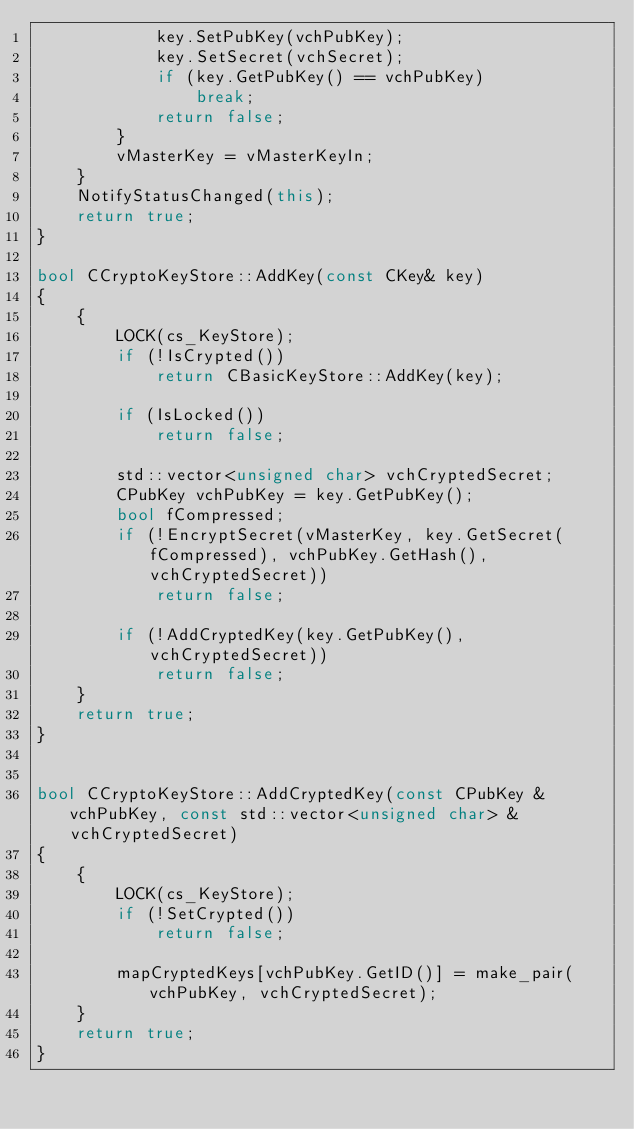<code> <loc_0><loc_0><loc_500><loc_500><_C++_>            key.SetPubKey(vchPubKey);
            key.SetSecret(vchSecret);
            if (key.GetPubKey() == vchPubKey)
                break;
            return false;
        }
        vMasterKey = vMasterKeyIn;
    }
    NotifyStatusChanged(this);
    return true;
}

bool CCryptoKeyStore::AddKey(const CKey& key)
{
    {
        LOCK(cs_KeyStore);
        if (!IsCrypted())
            return CBasicKeyStore::AddKey(key);

        if (IsLocked())
            return false;

        std::vector<unsigned char> vchCryptedSecret;
        CPubKey vchPubKey = key.GetPubKey();
        bool fCompressed;
        if (!EncryptSecret(vMasterKey, key.GetSecret(fCompressed), vchPubKey.GetHash(), vchCryptedSecret))
            return false;

        if (!AddCryptedKey(key.GetPubKey(), vchCryptedSecret))
            return false;
    }
    return true;
}


bool CCryptoKeyStore::AddCryptedKey(const CPubKey &vchPubKey, const std::vector<unsigned char> &vchCryptedSecret)
{
    {
        LOCK(cs_KeyStore);
        if (!SetCrypted())
            return false;

        mapCryptedKeys[vchPubKey.GetID()] = make_pair(vchPubKey, vchCryptedSecret);
    }
    return true;
}
</code> 